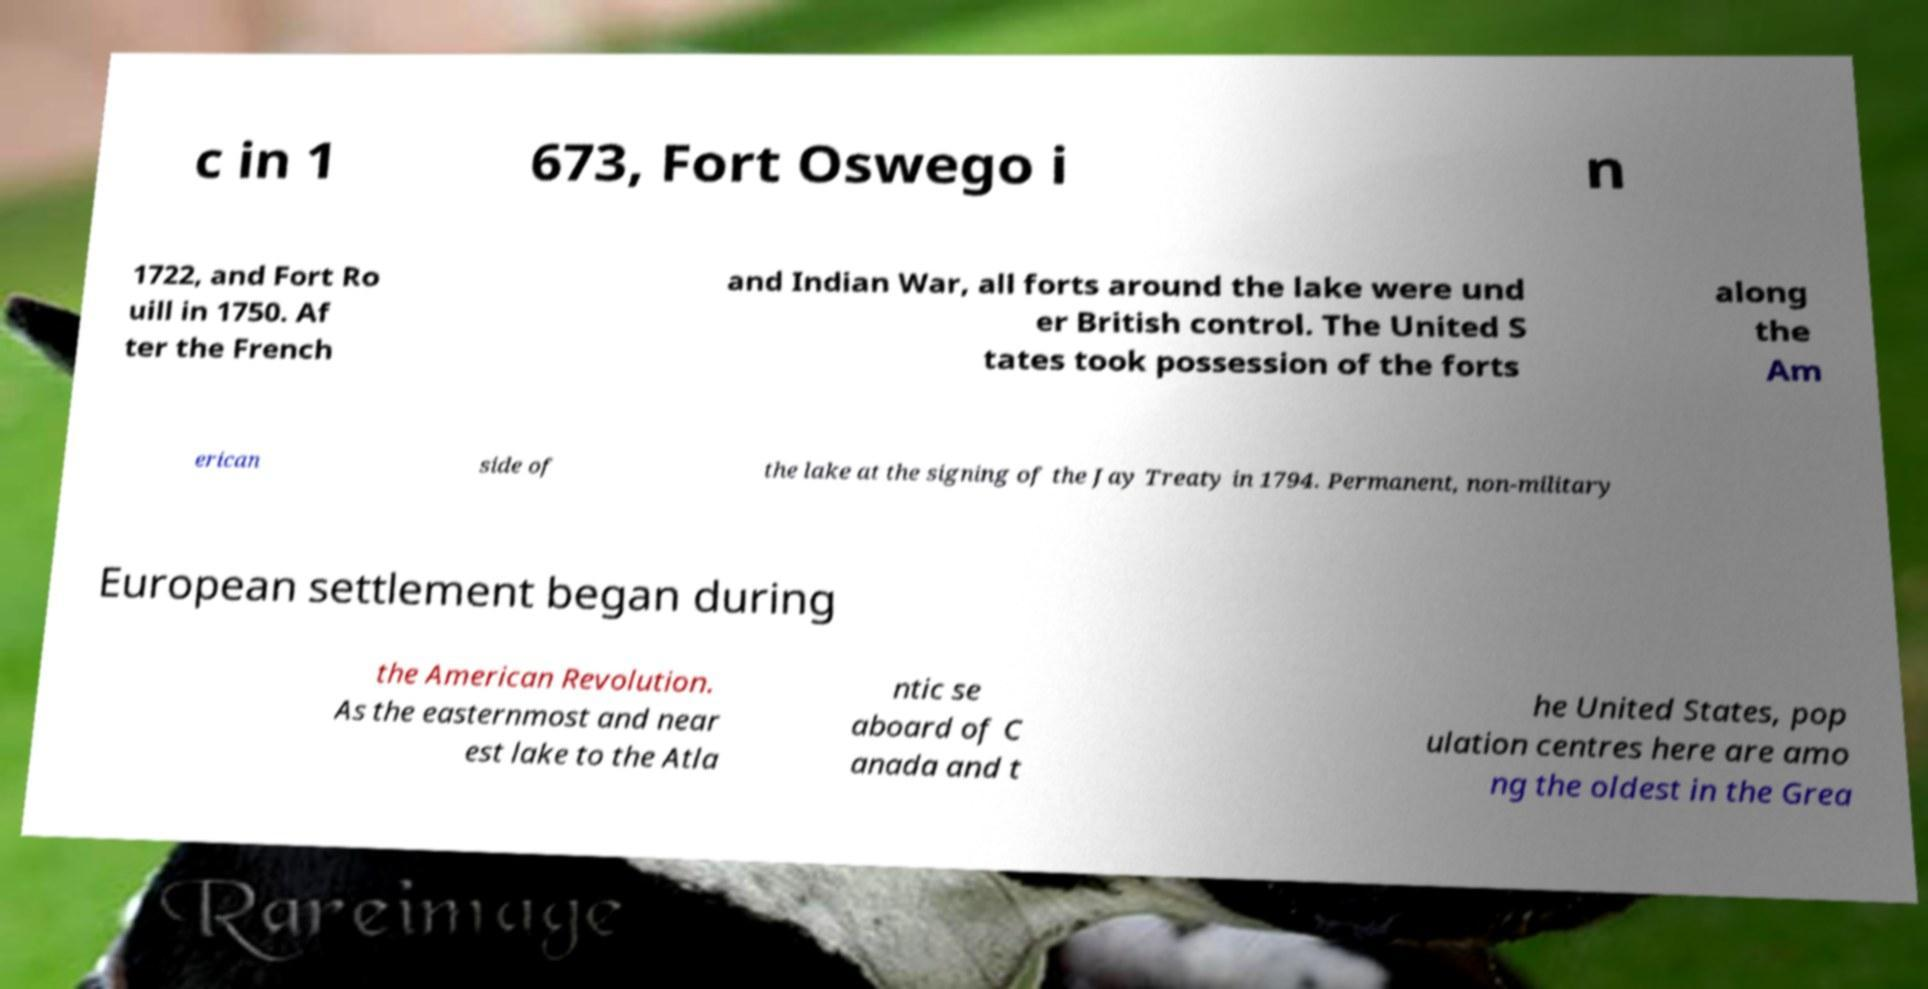There's text embedded in this image that I need extracted. Can you transcribe it verbatim? c in 1 673, Fort Oswego i n 1722, and Fort Ro uill in 1750. Af ter the French and Indian War, all forts around the lake were und er British control. The United S tates took possession of the forts along the Am erican side of the lake at the signing of the Jay Treaty in 1794. Permanent, non-military European settlement began during the American Revolution. As the easternmost and near est lake to the Atla ntic se aboard of C anada and t he United States, pop ulation centres here are amo ng the oldest in the Grea 